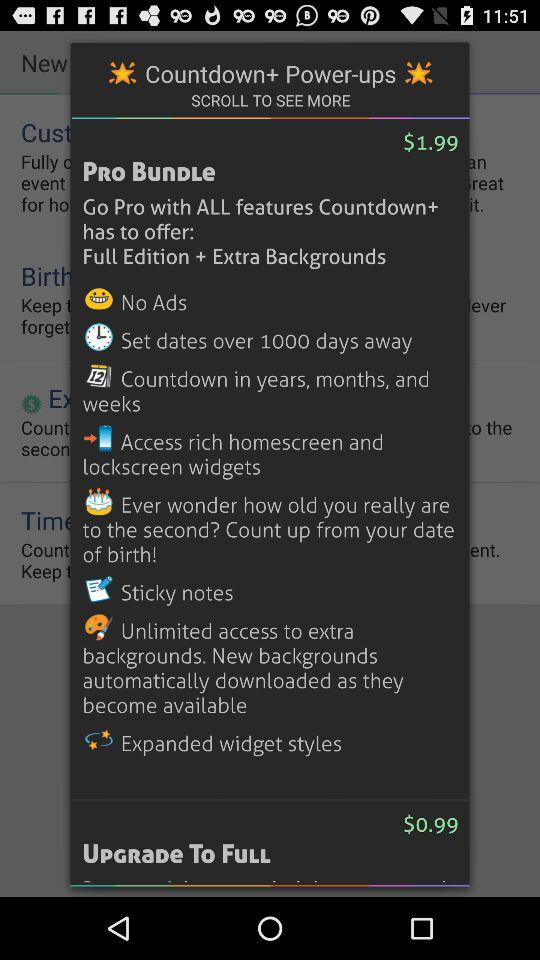What is the pro bundle price? The pro bundle price is $1.99. 